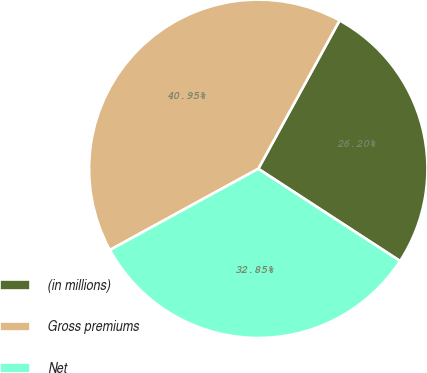<chart> <loc_0><loc_0><loc_500><loc_500><pie_chart><fcel>(in millions)<fcel>Gross premiums<fcel>Net<nl><fcel>26.2%<fcel>40.95%<fcel>32.85%<nl></chart> 